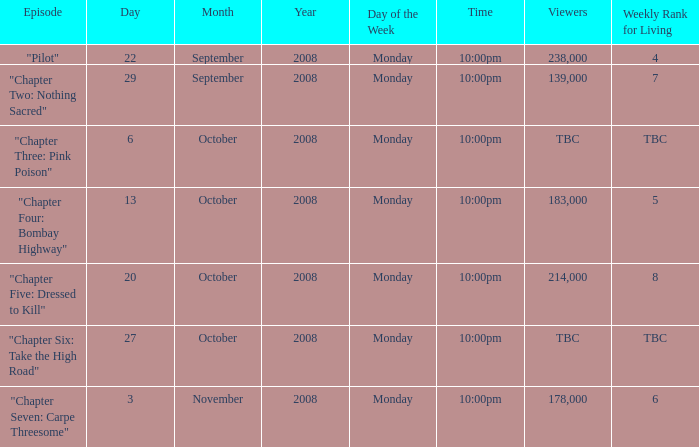How many viewers for the episode with the weekly rank for living of 4? 238000.0. 